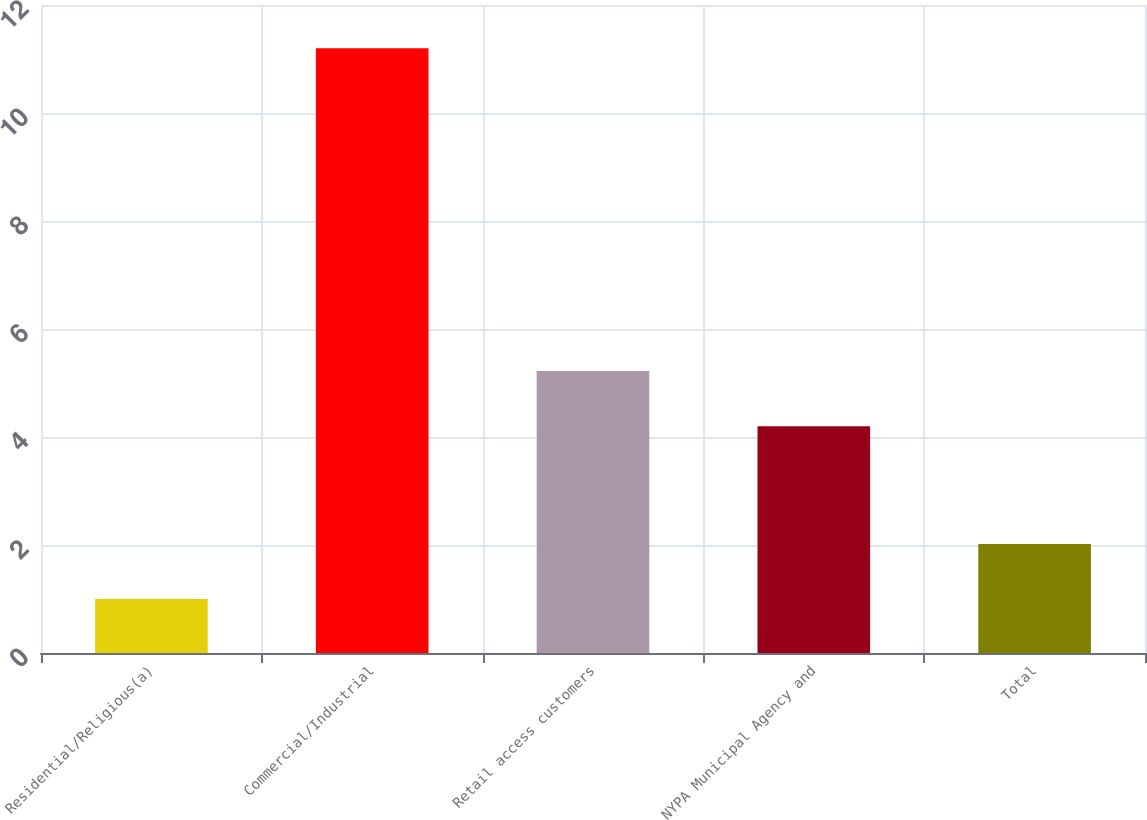<chart> <loc_0><loc_0><loc_500><loc_500><bar_chart><fcel>Residential/Religious(a)<fcel>Commercial/Industrial<fcel>Retail access customers<fcel>NYPA Municipal Agency and<fcel>Total<nl><fcel>1<fcel>11.2<fcel>5.22<fcel>4.2<fcel>2.02<nl></chart> 